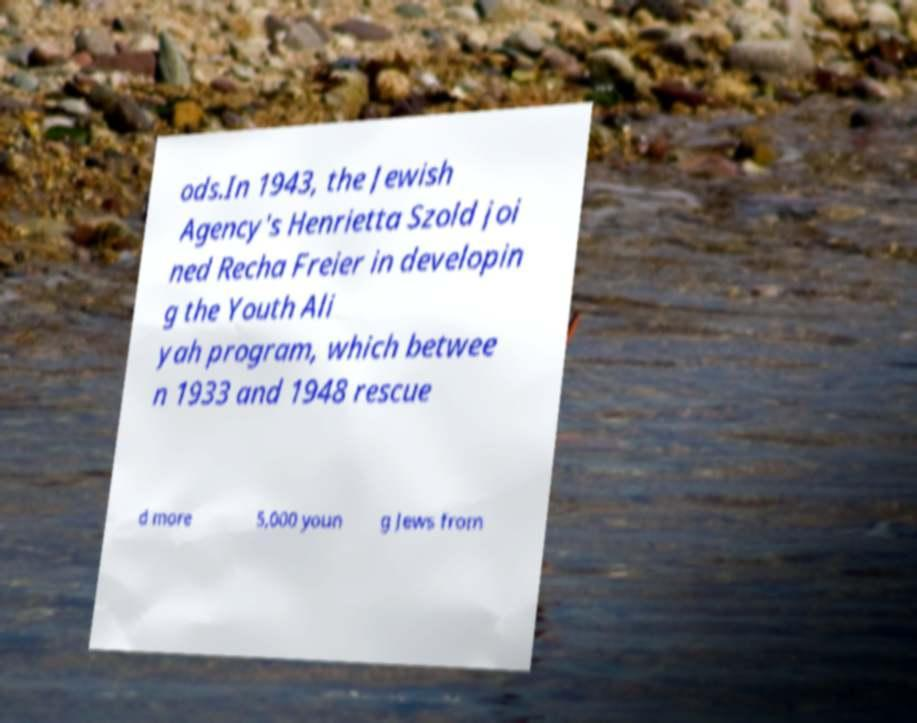Can you read and provide the text displayed in the image?This photo seems to have some interesting text. Can you extract and type it out for me? ods.In 1943, the Jewish Agency's Henrietta Szold joi ned Recha Freier in developin g the Youth Ali yah program, which betwee n 1933 and 1948 rescue d more 5,000 youn g Jews from 